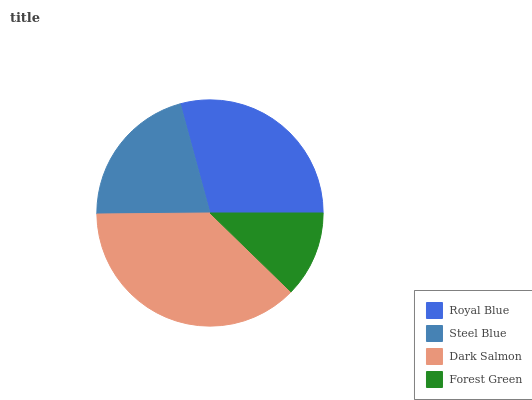Is Forest Green the minimum?
Answer yes or no. Yes. Is Dark Salmon the maximum?
Answer yes or no. Yes. Is Steel Blue the minimum?
Answer yes or no. No. Is Steel Blue the maximum?
Answer yes or no. No. Is Royal Blue greater than Steel Blue?
Answer yes or no. Yes. Is Steel Blue less than Royal Blue?
Answer yes or no. Yes. Is Steel Blue greater than Royal Blue?
Answer yes or no. No. Is Royal Blue less than Steel Blue?
Answer yes or no. No. Is Royal Blue the high median?
Answer yes or no. Yes. Is Steel Blue the low median?
Answer yes or no. Yes. Is Steel Blue the high median?
Answer yes or no. No. Is Dark Salmon the low median?
Answer yes or no. No. 